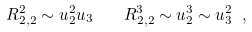<formula> <loc_0><loc_0><loc_500><loc_500>R ^ { 2 } _ { 2 , 2 } \sim u _ { 2 } ^ { 2 } u _ { 3 } \, \quad R ^ { 3 } _ { 2 , 2 } \sim u _ { 2 } ^ { 3 } \sim u _ { 3 } ^ { 2 } \ ,</formula> 